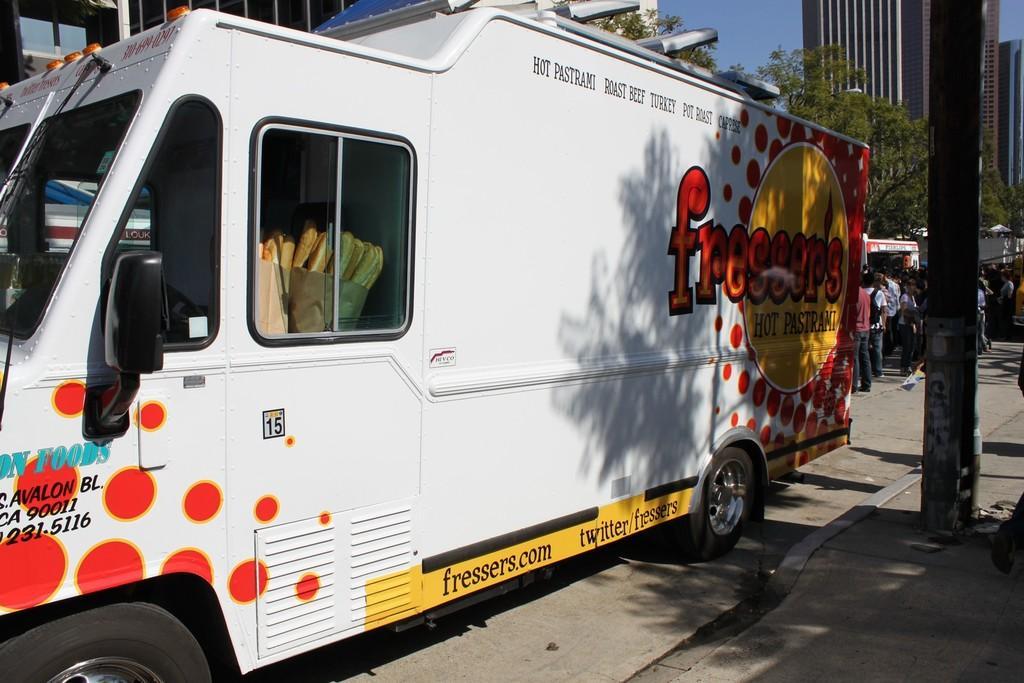Can you describe this image briefly? In this image we can see a few people, there are some food items in the truck, there are texts on the truck, there is a pole, and buildings, also we can see the sky. 